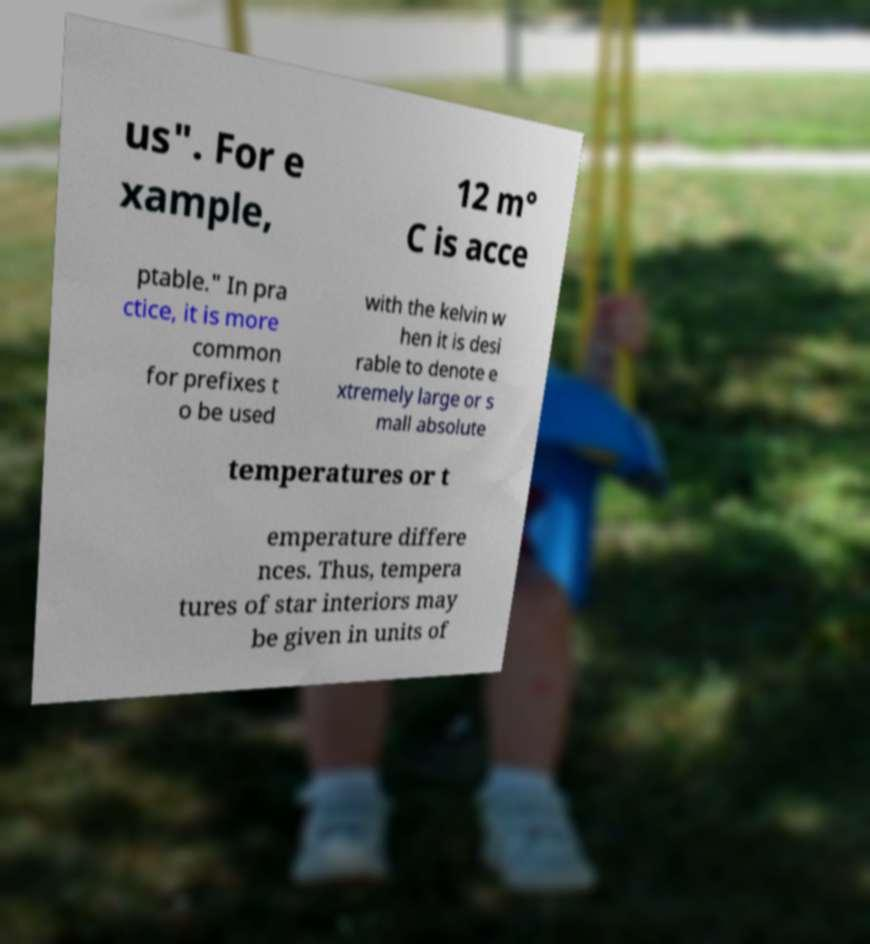Can you read and provide the text displayed in the image?This photo seems to have some interesting text. Can you extract and type it out for me? us". For e xample, 12 m° C is acce ptable." In pra ctice, it is more common for prefixes t o be used with the kelvin w hen it is desi rable to denote e xtremely large or s mall absolute temperatures or t emperature differe nces. Thus, tempera tures of star interiors may be given in units of 